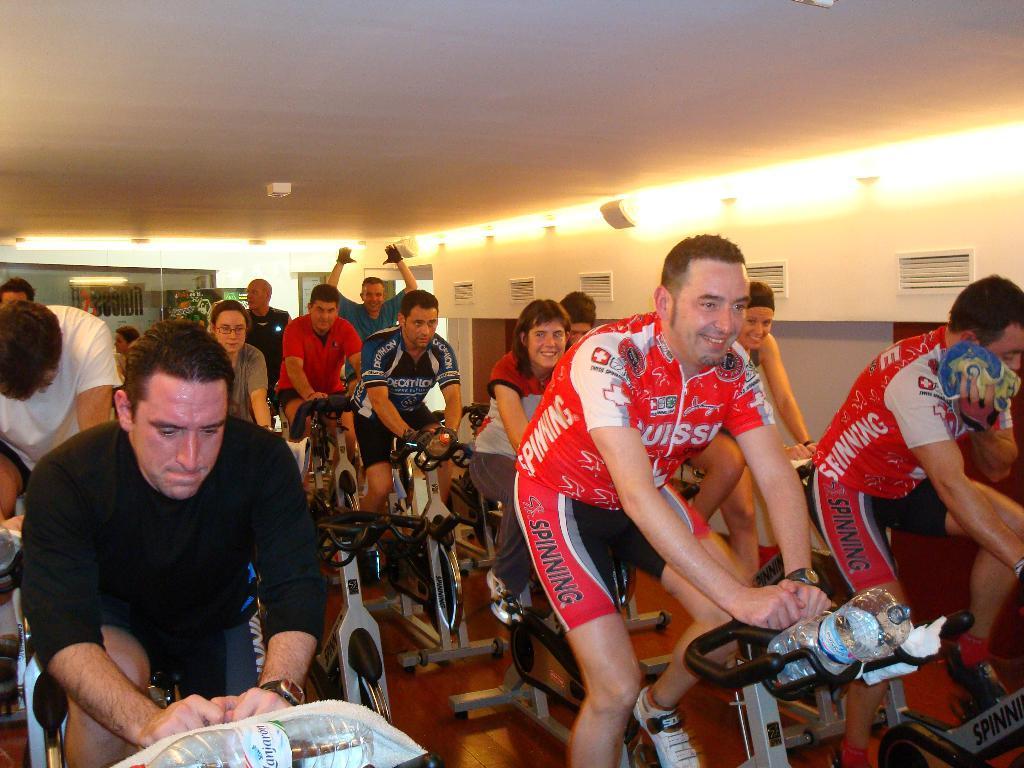In one or two sentences, can you explain what this image depicts? In the foreground of this image, there are people cycling on the gym cycles and we can also see bottles and few clothes. In the background, there is ceiling, lights and the wall. 